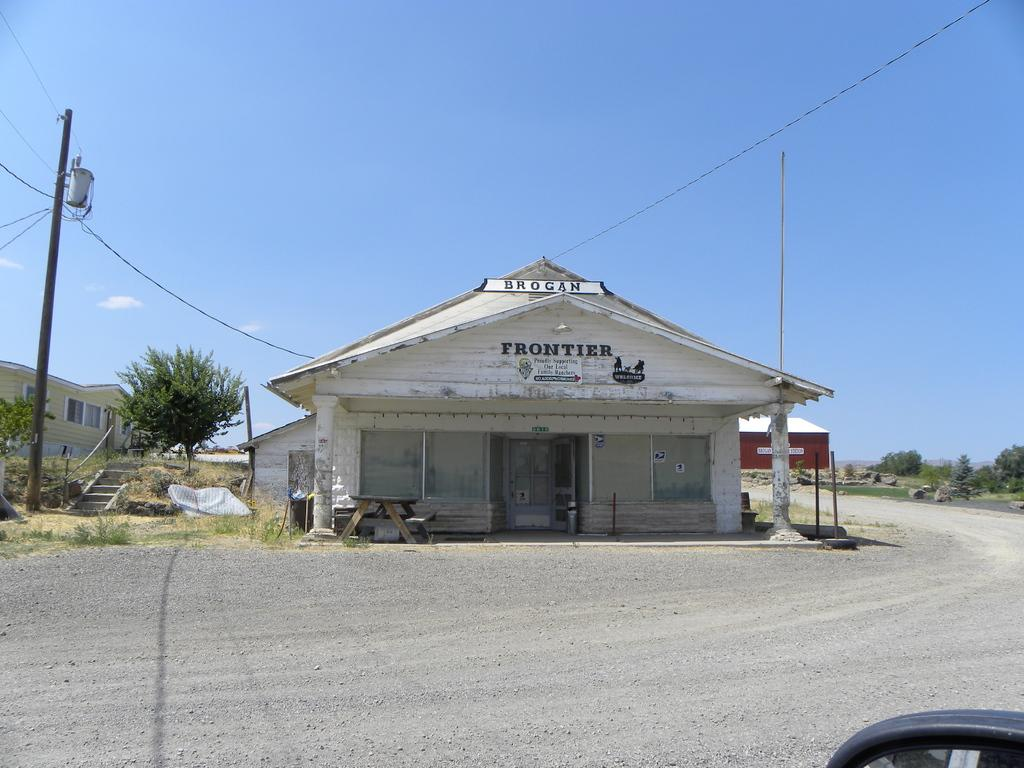What type of pathway is visible in the image? There is a road in the image. What type of structure can be seen near the road? There is a house in the image. What type of vegetation is present in the image? There are trees in the image. What type of infrastructure is present in the image? There is a pole with cables in the image. What is the condition of the sky in the image? The sky is clear in the image. Can you see a rose growing on the side of the road in the image? There is no rose visible in the image; it only features a road, a house, trees, a pole with cables, and a clear sky. Is there a boot lying on the road in the image? There is no boot present in the image; it only features a road, a house, trees, a pole with cables, and a clear sky. 